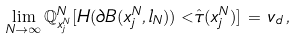<formula> <loc_0><loc_0><loc_500><loc_500>\lim _ { N \to \infty } \mathbb { Q } ^ { N } _ { x ^ { N } _ { j } } [ H ( \partial B ( x ^ { N } _ { j } , l _ { N } ) ) < \hat { \tau } ( x ^ { N } _ { j } ) ] \, = \, v _ { d } \, ,</formula> 